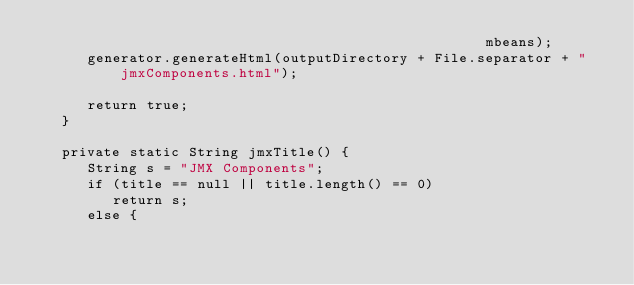<code> <loc_0><loc_0><loc_500><loc_500><_Java_>                                                     mbeans);
      generator.generateHtml(outputDirectory + File.separator + "jmxComponents.html");

      return true;
   }

   private static String jmxTitle() {
      String s = "JMX Components";
      if (title == null || title.length() == 0)
         return s;
      else {</code> 